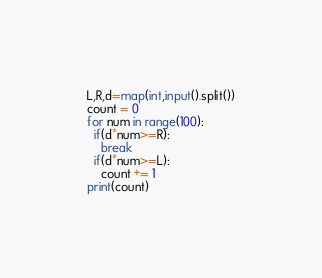Convert code to text. <code><loc_0><loc_0><loc_500><loc_500><_Python_>L,R,d=map(int,input().split())
count = 0
for num in range(100):
  if(d*num>=R):
    break
  if(d*num>=L):
    count += 1
print(count)</code> 